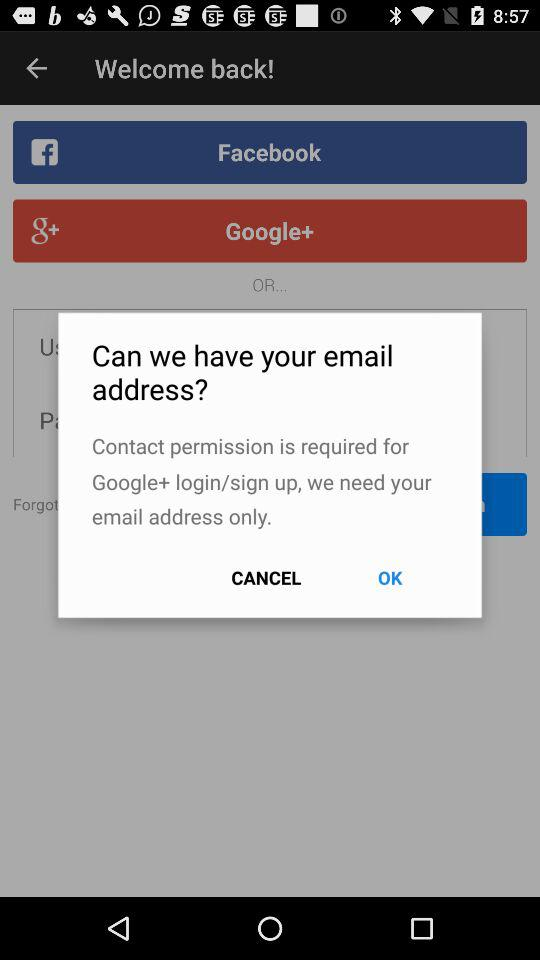For what application is contact permission required? Contact permission is required for "Google+". 